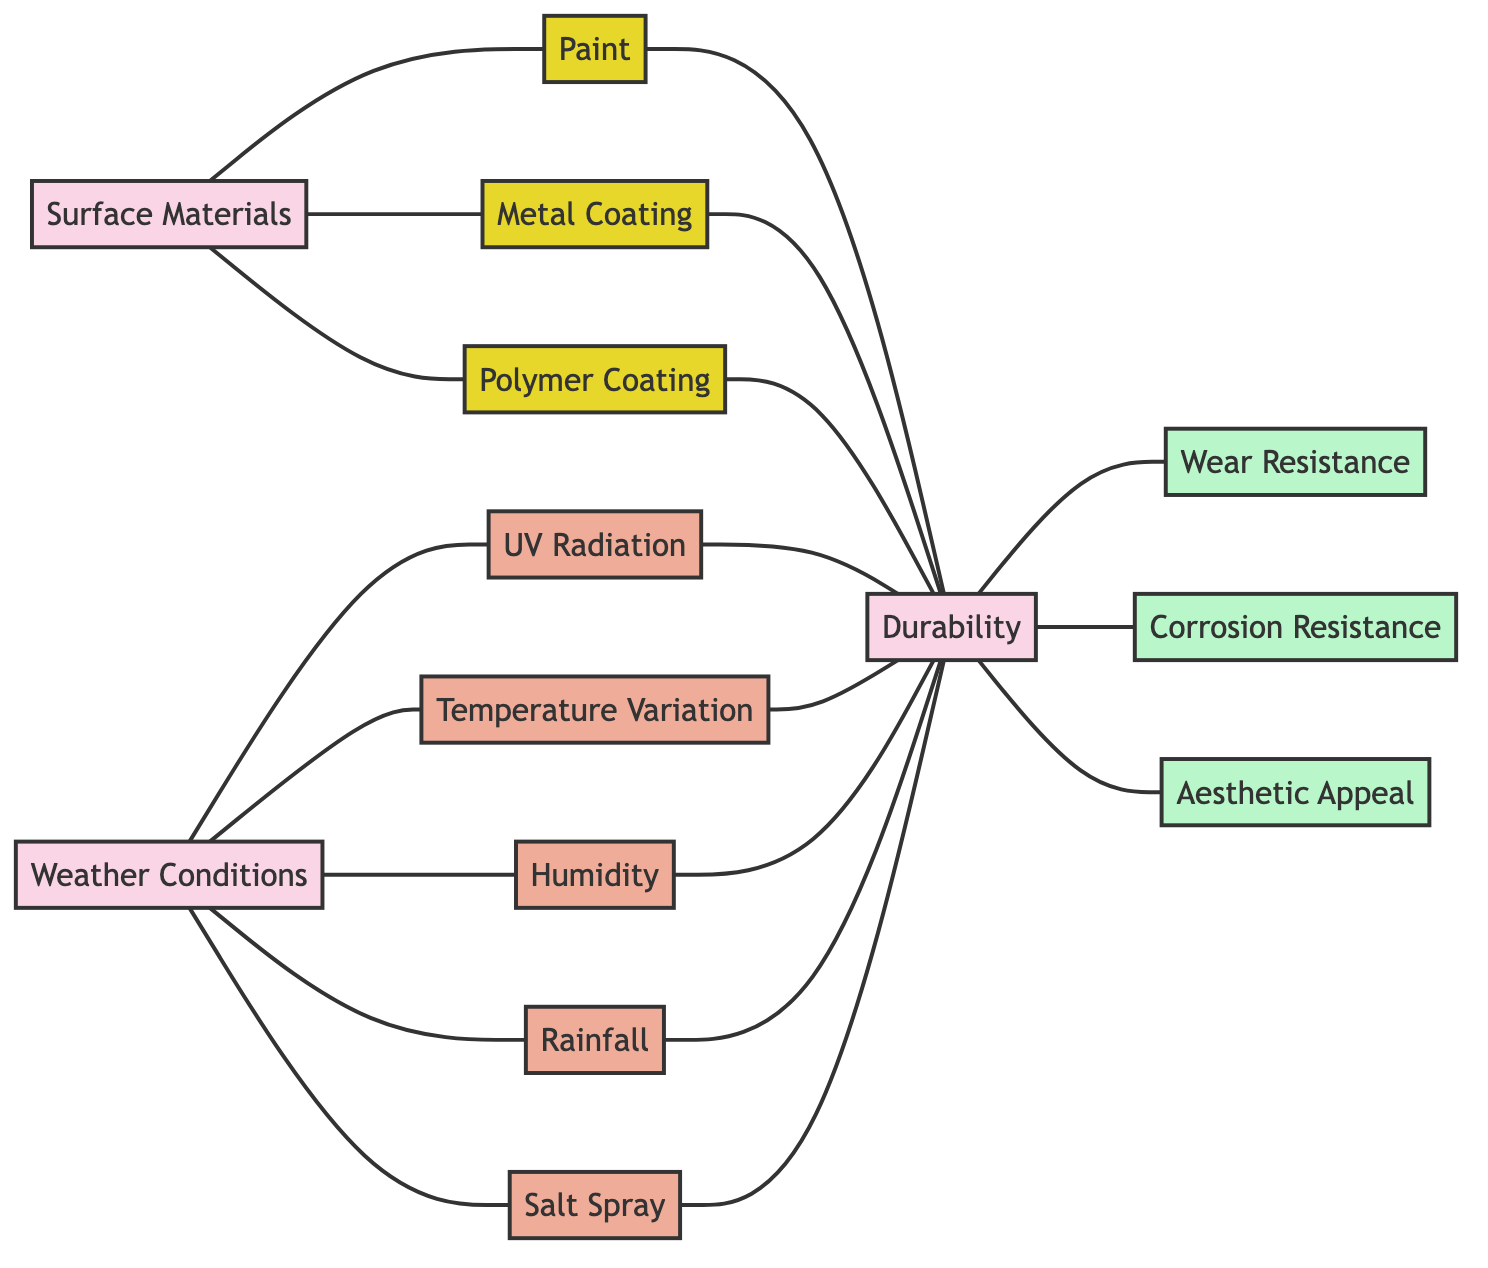What are the three types of surface materials? The diagram shows three nodes under "Surface Materials": Paint, Metal Coating, and Polymer Coating.
Answer: Paint, Metal Coating, Polymer Coating How many weather conditions are listed in the diagram? The diagram includes five nodes under "Weather Conditions": UV Radiation, Temperature Variation, Humidity, Rainfall, and Salt Spray. Counting these gives a total of five.
Answer: 5 What does "Durability" depend on? "Durability" depends on three properties: Wear Resistance, Corrosion Resistance, and includes Aesthetic Appeal. These relationships are indicated by the "depends_on" connections to these properties.
Answer: Wear Resistance, Corrosion Resistance, Aesthetic Appeal Which environmental factor influences durability the most? The diagram shows five environmental factors influencing "Durability": UV Radiation, Temperature Variation, Humidity, Rainfall, and Salt Spray. Since they all have direct influence connections, it's not possible to identify one as the most influential based on the diagram alone.
Answer: All equally influential What are the possible properties of durability? The properties associated with "Durability" are represented in the diagram as Wear Resistance, Corrosion Resistance, and Aesthetic Appeal. These properties can be evaluated to assess the durability of surface materials under different conditions.
Answer: Wear Resistance, Corrosion Resistance, Aesthetic Appeal How many edges are connected to "Surface Materials"? The diagram shows three edges connected to "Surface Materials" indicating relationships to Paint, Metal Coating, and Polymer Coating. Additionally, each of these materials has edges representing their effects on durability, resulting in a total of six edges connected to "Surface Materials".
Answer: 6 Which weather condition includes humidity? The diagram shows the connection from "Weather Conditions" to "Humidity," which is specifically labeled as one of the factors included. Hence, the answer is "Humidity."
Answer: Humidity How many materials affect durability? The diagram indicates that all three surface materials (Paint, Metal Coating, Polymer Coating) affect "Durability." This means that a total of three materials contribute to its durability.
Answer: 3 